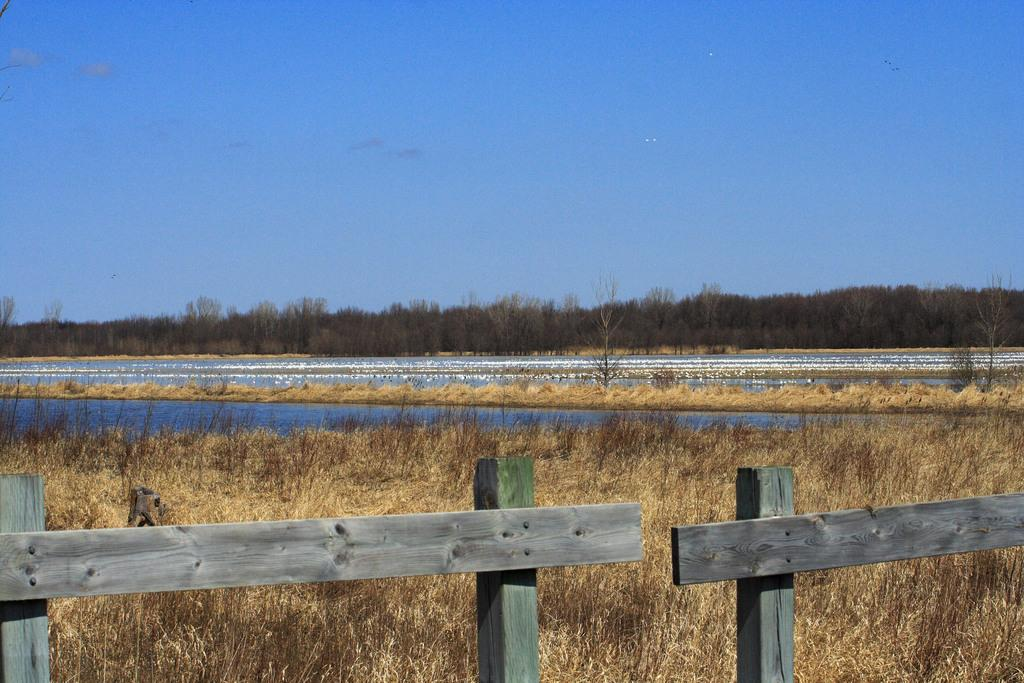What type of barrier is present in the image? There is a wooden fence in the image. What natural element can be seen in the image? There is water visible in the image. What type of vegetation is present in the image? There are trees in the image. What is visible in the background of the image? The sky is visible in the image. What type of lock is holding the trees together in the image? There is no lock present in the image, and the trees are not held together. How many loaves of bread can be seen in the image? There is no bread present in the image. 